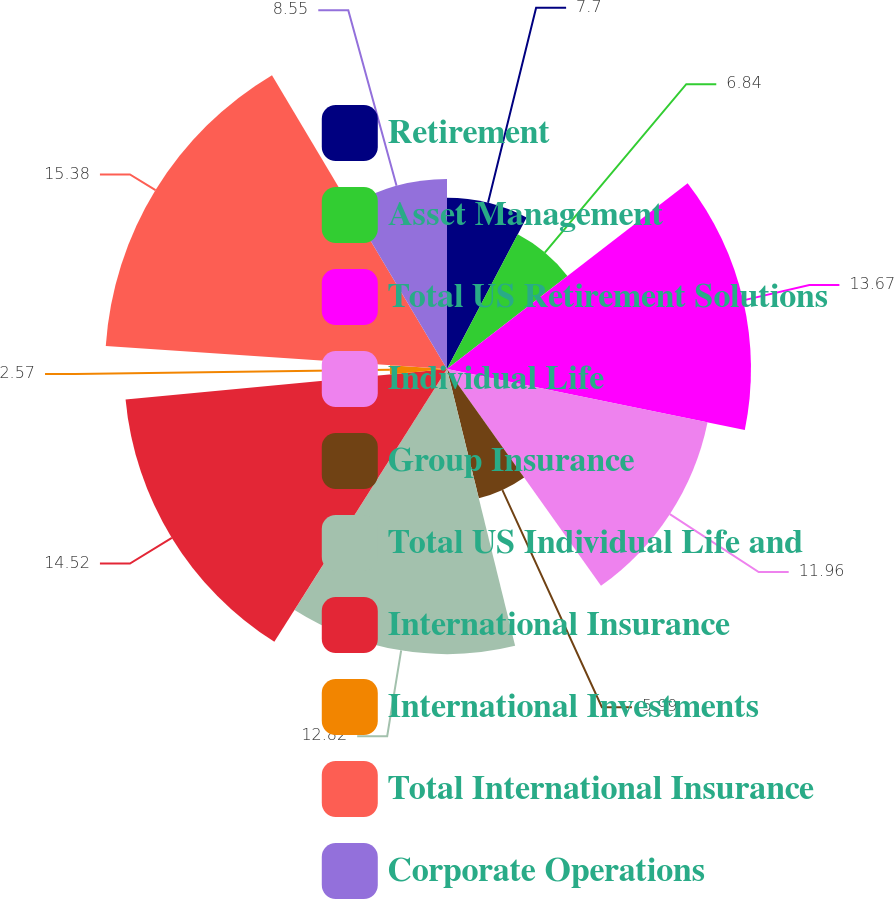Convert chart. <chart><loc_0><loc_0><loc_500><loc_500><pie_chart><fcel>Retirement<fcel>Asset Management<fcel>Total US Retirement Solutions<fcel>Individual Life<fcel>Group Insurance<fcel>Total US Individual Life and<fcel>International Insurance<fcel>International Investments<fcel>Total International Insurance<fcel>Corporate Operations<nl><fcel>7.7%<fcel>6.84%<fcel>13.67%<fcel>11.96%<fcel>5.99%<fcel>12.82%<fcel>14.52%<fcel>2.57%<fcel>15.38%<fcel>8.55%<nl></chart> 